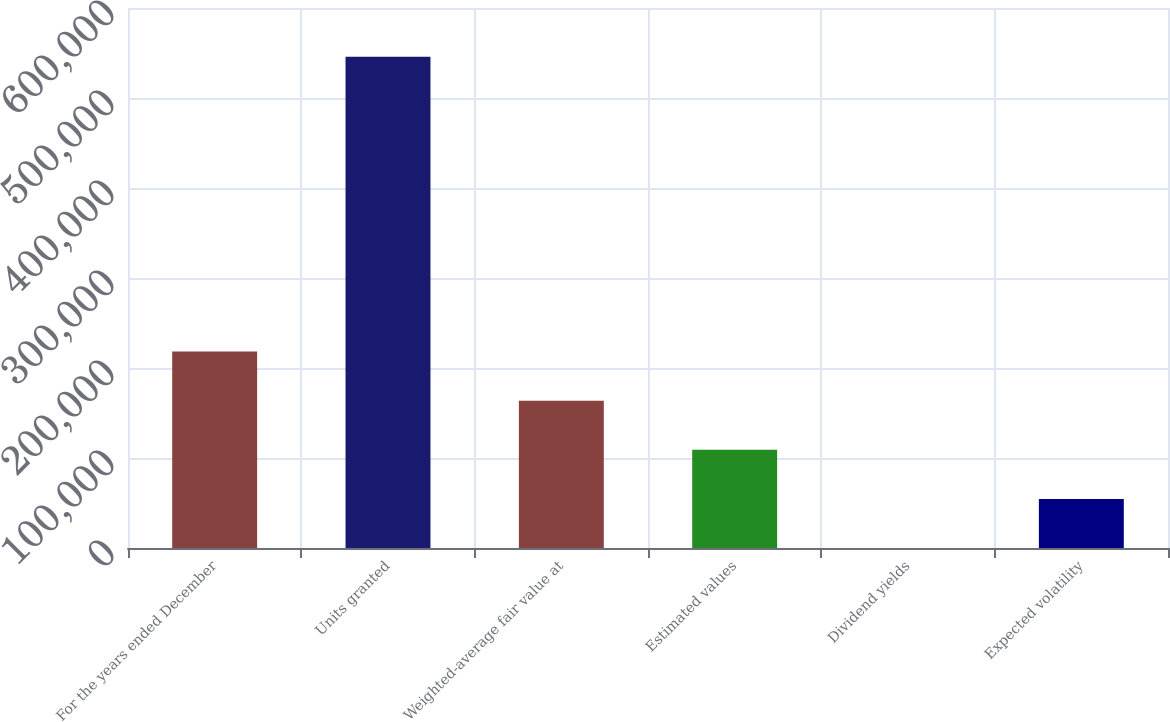Convert chart to OTSL. <chart><loc_0><loc_0><loc_500><loc_500><bar_chart><fcel>For the years ended December<fcel>Units granted<fcel>Weighted-average fair value at<fcel>Estimated values<fcel>Dividend yields<fcel>Expected volatility<nl><fcel>218302<fcel>545750<fcel>163727<fcel>109152<fcel>2.5<fcel>54577.2<nl></chart> 